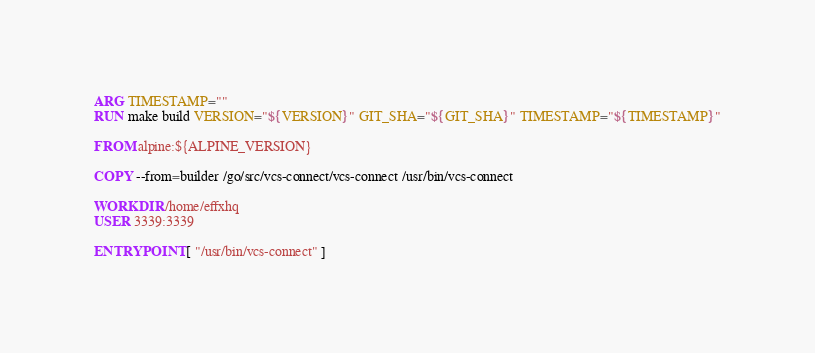Convert code to text. <code><loc_0><loc_0><loc_500><loc_500><_Dockerfile_>ARG TIMESTAMP=""
RUN make build VERSION="${VERSION}" GIT_SHA="${GIT_SHA}" TIMESTAMP="${TIMESTAMP}"

FROM alpine:${ALPINE_VERSION}

COPY --from=builder /go/src/vcs-connect/vcs-connect /usr/bin/vcs-connect

WORKDIR /home/effxhq
USER 3339:3339

ENTRYPOINT [ "/usr/bin/vcs-connect" ]
</code> 